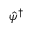Convert formula to latex. <formula><loc_0><loc_0><loc_500><loc_500>\hat { \psi } ^ { \dagger }</formula> 